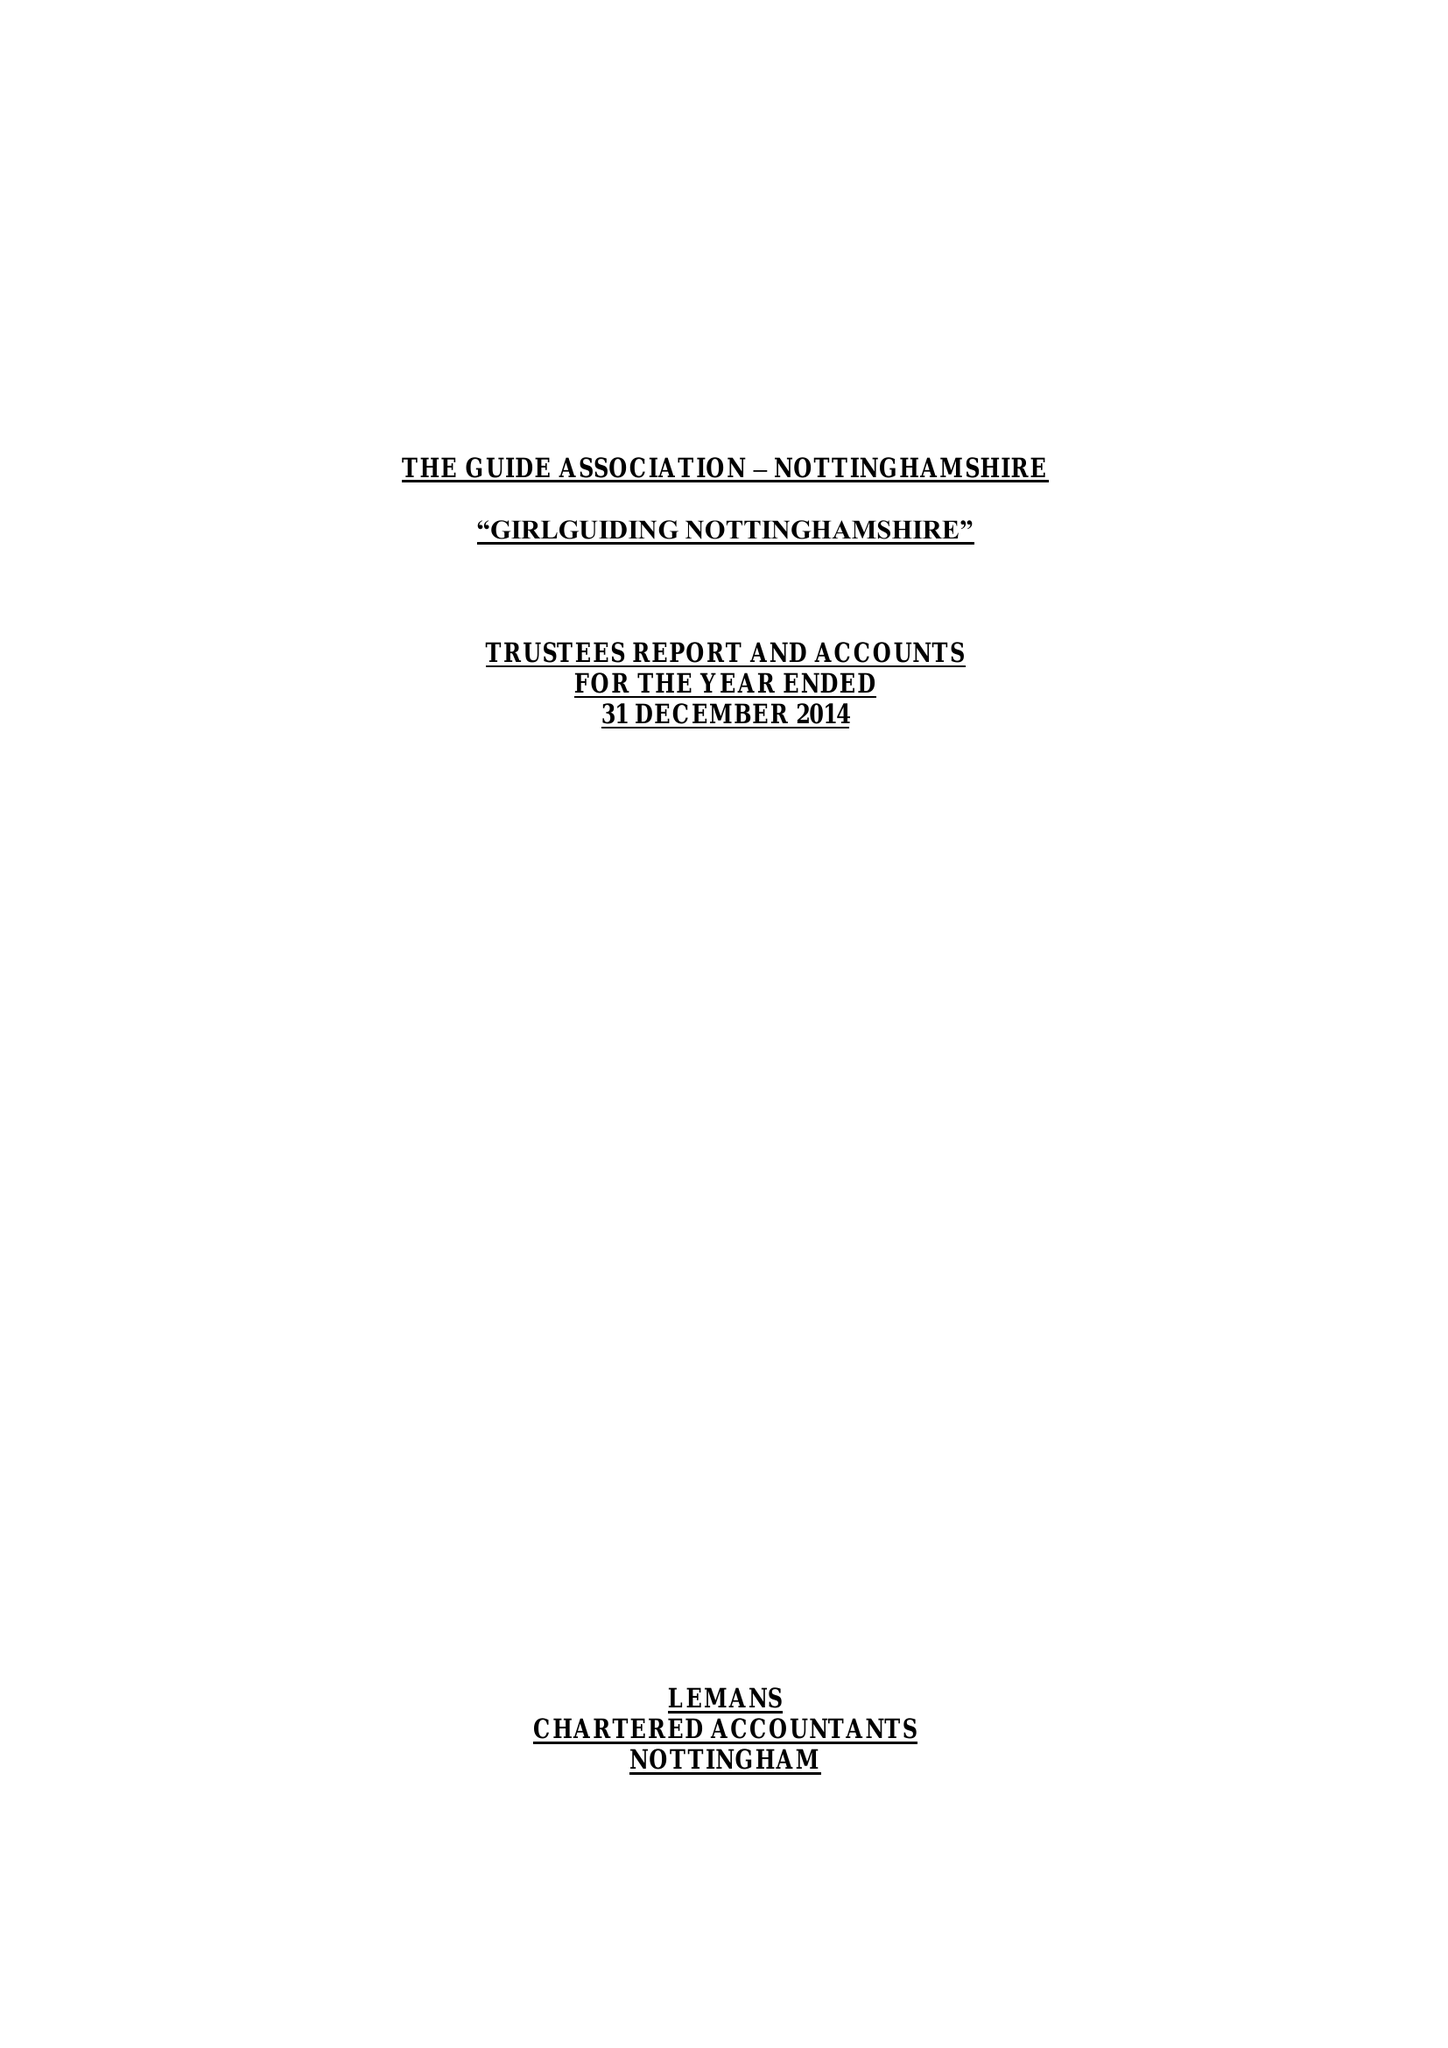What is the value for the charity_number?
Answer the question using a single word or phrase. 503168 